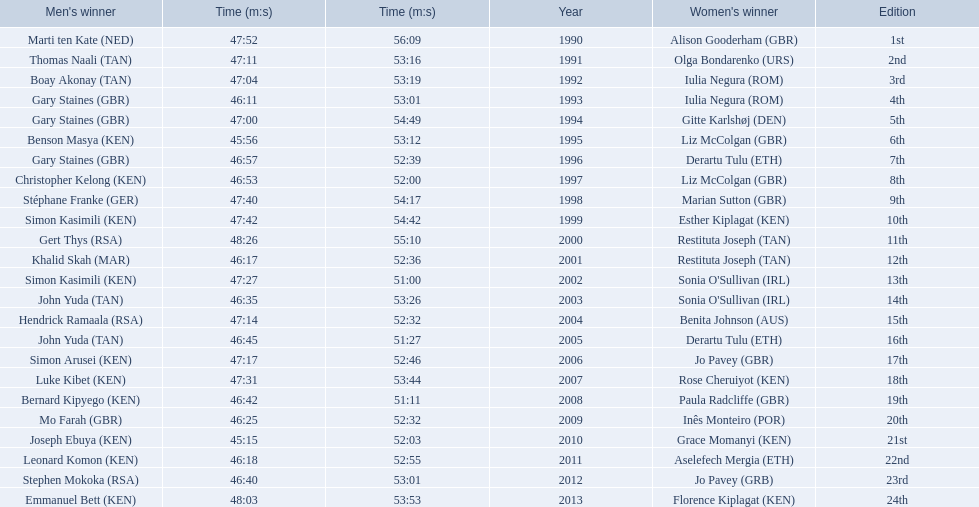Which runners are from kenya? (ken) Benson Masya (KEN), Christopher Kelong (KEN), Simon Kasimili (KEN), Simon Kasimili (KEN), Simon Arusei (KEN), Luke Kibet (KEN), Bernard Kipyego (KEN), Joseph Ebuya (KEN), Leonard Komon (KEN), Emmanuel Bett (KEN). Could you parse the entire table as a dict? {'header': ["Men's winner", 'Time (m:s)', 'Time (m:s)', 'Year', "Women's winner", 'Edition'], 'rows': [['Marti ten Kate\xa0(NED)', '47:52', '56:09', '1990', 'Alison Gooderham\xa0(GBR)', '1st'], ['Thomas Naali\xa0(TAN)', '47:11', '53:16', '1991', 'Olga Bondarenko\xa0(URS)', '2nd'], ['Boay Akonay\xa0(TAN)', '47:04', '53:19', '1992', 'Iulia Negura\xa0(ROM)', '3rd'], ['Gary Staines\xa0(GBR)', '46:11', '53:01', '1993', 'Iulia Negura\xa0(ROM)', '4th'], ['Gary Staines\xa0(GBR)', '47:00', '54:49', '1994', 'Gitte Karlshøj\xa0(DEN)', '5th'], ['Benson Masya\xa0(KEN)', '45:56', '53:12', '1995', 'Liz McColgan\xa0(GBR)', '6th'], ['Gary Staines\xa0(GBR)', '46:57', '52:39', '1996', 'Derartu Tulu\xa0(ETH)', '7th'], ['Christopher Kelong\xa0(KEN)', '46:53', '52:00', '1997', 'Liz McColgan\xa0(GBR)', '8th'], ['Stéphane Franke\xa0(GER)', '47:40', '54:17', '1998', 'Marian Sutton\xa0(GBR)', '9th'], ['Simon Kasimili\xa0(KEN)', '47:42', '54:42', '1999', 'Esther Kiplagat\xa0(KEN)', '10th'], ['Gert Thys\xa0(RSA)', '48:26', '55:10', '2000', 'Restituta Joseph\xa0(TAN)', '11th'], ['Khalid Skah\xa0(MAR)', '46:17', '52:36', '2001', 'Restituta Joseph\xa0(TAN)', '12th'], ['Simon Kasimili\xa0(KEN)', '47:27', '51:00', '2002', "Sonia O'Sullivan\xa0(IRL)", '13th'], ['John Yuda\xa0(TAN)', '46:35', '53:26', '2003', "Sonia O'Sullivan\xa0(IRL)", '14th'], ['Hendrick Ramaala\xa0(RSA)', '47:14', '52:32', '2004', 'Benita Johnson\xa0(AUS)', '15th'], ['John Yuda\xa0(TAN)', '46:45', '51:27', '2005', 'Derartu Tulu\xa0(ETH)', '16th'], ['Simon Arusei\xa0(KEN)', '47:17', '52:46', '2006', 'Jo Pavey\xa0(GBR)', '17th'], ['Luke Kibet\xa0(KEN)', '47:31', '53:44', '2007', 'Rose Cheruiyot\xa0(KEN)', '18th'], ['Bernard Kipyego\xa0(KEN)', '46:42', '51:11', '2008', 'Paula Radcliffe\xa0(GBR)', '19th'], ['Mo Farah\xa0(GBR)', '46:25', '52:32', '2009', 'Inês Monteiro\xa0(POR)', '20th'], ['Joseph Ebuya\xa0(KEN)', '45:15', '52:03', '2010', 'Grace Momanyi\xa0(KEN)', '21st'], ['Leonard Komon\xa0(KEN)', '46:18', '52:55', '2011', 'Aselefech Mergia\xa0(ETH)', '22nd'], ['Stephen Mokoka\xa0(RSA)', '46:40', '53:01', '2012', 'Jo Pavey\xa0(GRB)', '23rd'], ['Emmanuel Bett\xa0(KEN)', '48:03', '53:53', '2013', 'Florence Kiplagat\xa0(KEN)', '24th']]} Of these, which times are under 46 minutes? Benson Masya (KEN), Joseph Ebuya (KEN). Which of these runners had the faster time? Joseph Ebuya (KEN). 